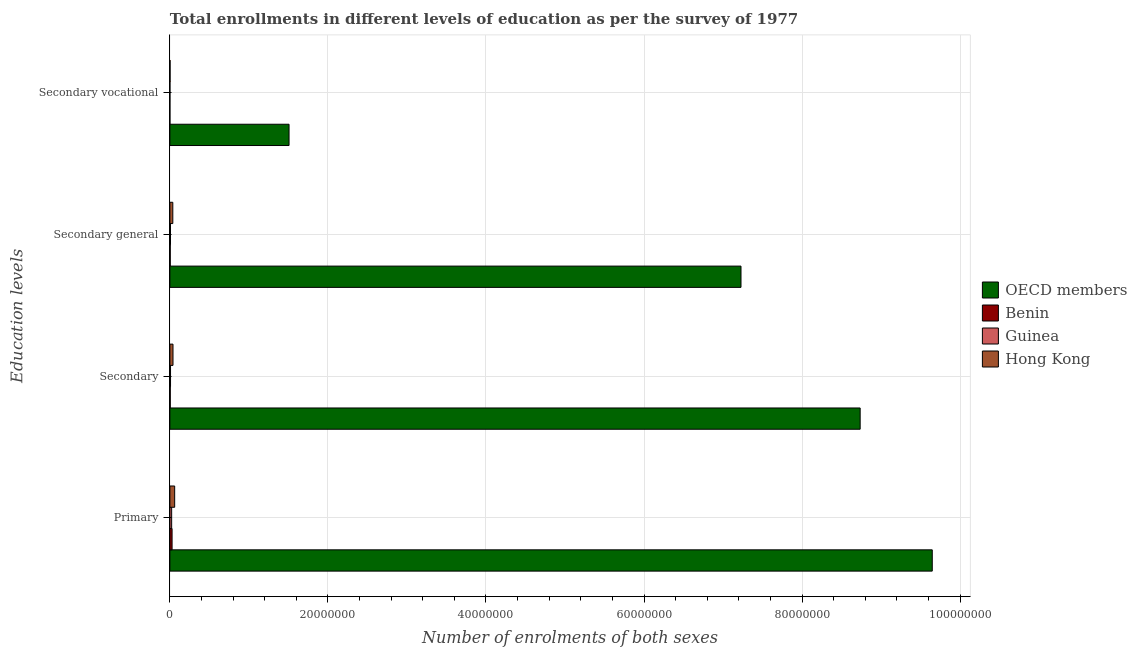How many different coloured bars are there?
Provide a short and direct response. 4. Are the number of bars per tick equal to the number of legend labels?
Your response must be concise. Yes. What is the label of the 4th group of bars from the top?
Ensure brevity in your answer.  Primary. What is the number of enrolments in secondary education in Benin?
Provide a succinct answer. 4.74e+04. Across all countries, what is the maximum number of enrolments in secondary general education?
Keep it short and to the point. 7.23e+07. Across all countries, what is the minimum number of enrolments in secondary education?
Provide a short and direct response. 4.74e+04. In which country was the number of enrolments in primary education minimum?
Provide a succinct answer. Guinea. What is the total number of enrolments in secondary education in the graph?
Offer a very short reply. 8.79e+07. What is the difference between the number of enrolments in primary education in OECD members and that in Benin?
Offer a terse response. 9.62e+07. What is the difference between the number of enrolments in secondary education in Benin and the number of enrolments in secondary general education in Guinea?
Provide a succinct answer. -3.11e+04. What is the average number of enrolments in secondary general education per country?
Keep it short and to the point. 1.82e+07. What is the difference between the number of enrolments in secondary general education and number of enrolments in secondary vocational education in Benin?
Your answer should be compact. 4.38e+04. In how many countries, is the number of enrolments in secondary vocational education greater than 32000000 ?
Make the answer very short. 0. What is the ratio of the number of enrolments in secondary education in Guinea to that in OECD members?
Offer a terse response. 0. Is the difference between the number of enrolments in secondary vocational education in OECD members and Benin greater than the difference between the number of enrolments in secondary education in OECD members and Benin?
Offer a very short reply. No. What is the difference between the highest and the second highest number of enrolments in secondary general education?
Keep it short and to the point. 7.19e+07. What is the difference between the highest and the lowest number of enrolments in secondary education?
Provide a succinct answer. 8.73e+07. What does the 3rd bar from the top in Primary represents?
Your answer should be very brief. Benin. Are all the bars in the graph horizontal?
Provide a short and direct response. Yes. Are the values on the major ticks of X-axis written in scientific E-notation?
Your answer should be very brief. No. How many legend labels are there?
Your response must be concise. 4. What is the title of the graph?
Ensure brevity in your answer.  Total enrollments in different levels of education as per the survey of 1977. Does "Ethiopia" appear as one of the legend labels in the graph?
Offer a very short reply. No. What is the label or title of the X-axis?
Offer a very short reply. Number of enrolments of both sexes. What is the label or title of the Y-axis?
Provide a succinct answer. Education levels. What is the Number of enrolments of both sexes in OECD members in Primary?
Ensure brevity in your answer.  9.65e+07. What is the Number of enrolments of both sexes in Benin in Primary?
Your answer should be very brief. 2.80e+05. What is the Number of enrolments of both sexes in Guinea in Primary?
Your response must be concise. 2.26e+05. What is the Number of enrolments of both sexes of Hong Kong in Primary?
Keep it short and to the point. 6.07e+05. What is the Number of enrolments of both sexes in OECD members in Secondary?
Keep it short and to the point. 8.73e+07. What is the Number of enrolments of both sexes in Benin in Secondary?
Provide a short and direct response. 4.74e+04. What is the Number of enrolments of both sexes in Guinea in Secondary?
Offer a terse response. 8.30e+04. What is the Number of enrolments of both sexes of Hong Kong in Secondary?
Your answer should be compact. 3.96e+05. What is the Number of enrolments of both sexes in OECD members in Secondary general?
Give a very brief answer. 7.23e+07. What is the Number of enrolments of both sexes of Benin in Secondary general?
Offer a very short reply. 4.56e+04. What is the Number of enrolments of both sexes in Guinea in Secondary general?
Ensure brevity in your answer.  7.85e+04. What is the Number of enrolments of both sexes in Hong Kong in Secondary general?
Make the answer very short. 3.72e+05. What is the Number of enrolments of both sexes of OECD members in Secondary vocational?
Give a very brief answer. 1.51e+07. What is the Number of enrolments of both sexes in Benin in Secondary vocational?
Offer a very short reply. 1798. What is the Number of enrolments of both sexes of Guinea in Secondary vocational?
Make the answer very short. 4560. What is the Number of enrolments of both sexes in Hong Kong in Secondary vocational?
Keep it short and to the point. 2.35e+04. Across all Education levels, what is the maximum Number of enrolments of both sexes of OECD members?
Ensure brevity in your answer.  9.65e+07. Across all Education levels, what is the maximum Number of enrolments of both sexes of Benin?
Your answer should be very brief. 2.80e+05. Across all Education levels, what is the maximum Number of enrolments of both sexes of Guinea?
Your response must be concise. 2.26e+05. Across all Education levels, what is the maximum Number of enrolments of both sexes of Hong Kong?
Keep it short and to the point. 6.07e+05. Across all Education levels, what is the minimum Number of enrolments of both sexes in OECD members?
Provide a succinct answer. 1.51e+07. Across all Education levels, what is the minimum Number of enrolments of both sexes in Benin?
Ensure brevity in your answer.  1798. Across all Education levels, what is the minimum Number of enrolments of both sexes in Guinea?
Make the answer very short. 4560. Across all Education levels, what is the minimum Number of enrolments of both sexes in Hong Kong?
Keep it short and to the point. 2.35e+04. What is the total Number of enrolments of both sexes of OECD members in the graph?
Make the answer very short. 2.71e+08. What is the total Number of enrolments of both sexes in Benin in the graph?
Provide a short and direct response. 3.74e+05. What is the total Number of enrolments of both sexes in Guinea in the graph?
Your answer should be very brief. 3.92e+05. What is the total Number of enrolments of both sexes in Hong Kong in the graph?
Provide a short and direct response. 1.40e+06. What is the difference between the Number of enrolments of both sexes of OECD members in Primary and that in Secondary?
Provide a succinct answer. 9.12e+06. What is the difference between the Number of enrolments of both sexes in Benin in Primary and that in Secondary?
Offer a terse response. 2.32e+05. What is the difference between the Number of enrolments of both sexes in Guinea in Primary and that in Secondary?
Offer a terse response. 1.43e+05. What is the difference between the Number of enrolments of both sexes of Hong Kong in Primary and that in Secondary?
Ensure brevity in your answer.  2.11e+05. What is the difference between the Number of enrolments of both sexes of OECD members in Primary and that in Secondary general?
Give a very brief answer. 2.42e+07. What is the difference between the Number of enrolments of both sexes of Benin in Primary and that in Secondary general?
Keep it short and to the point. 2.34e+05. What is the difference between the Number of enrolments of both sexes in Guinea in Primary and that in Secondary general?
Make the answer very short. 1.47e+05. What is the difference between the Number of enrolments of both sexes in Hong Kong in Primary and that in Secondary general?
Your answer should be compact. 2.35e+05. What is the difference between the Number of enrolments of both sexes in OECD members in Primary and that in Secondary vocational?
Keep it short and to the point. 8.14e+07. What is the difference between the Number of enrolments of both sexes in Benin in Primary and that in Secondary vocational?
Keep it short and to the point. 2.78e+05. What is the difference between the Number of enrolments of both sexes in Guinea in Primary and that in Secondary vocational?
Keep it short and to the point. 2.21e+05. What is the difference between the Number of enrolments of both sexes of Hong Kong in Primary and that in Secondary vocational?
Make the answer very short. 5.83e+05. What is the difference between the Number of enrolments of both sexes of OECD members in Secondary and that in Secondary general?
Keep it short and to the point. 1.51e+07. What is the difference between the Number of enrolments of both sexes of Benin in Secondary and that in Secondary general?
Make the answer very short. 1798. What is the difference between the Number of enrolments of both sexes of Guinea in Secondary and that in Secondary general?
Your answer should be compact. 4560. What is the difference between the Number of enrolments of both sexes in Hong Kong in Secondary and that in Secondary general?
Ensure brevity in your answer.  2.35e+04. What is the difference between the Number of enrolments of both sexes of OECD members in Secondary and that in Secondary vocational?
Make the answer very short. 7.23e+07. What is the difference between the Number of enrolments of both sexes of Benin in Secondary and that in Secondary vocational?
Keep it short and to the point. 4.56e+04. What is the difference between the Number of enrolments of both sexes in Guinea in Secondary and that in Secondary vocational?
Offer a very short reply. 7.85e+04. What is the difference between the Number of enrolments of both sexes in Hong Kong in Secondary and that in Secondary vocational?
Provide a succinct answer. 3.72e+05. What is the difference between the Number of enrolments of both sexes of OECD members in Secondary general and that in Secondary vocational?
Your answer should be very brief. 5.72e+07. What is the difference between the Number of enrolments of both sexes of Benin in Secondary general and that in Secondary vocational?
Your answer should be compact. 4.38e+04. What is the difference between the Number of enrolments of both sexes of Guinea in Secondary general and that in Secondary vocational?
Your answer should be very brief. 7.39e+04. What is the difference between the Number of enrolments of both sexes of Hong Kong in Secondary general and that in Secondary vocational?
Offer a terse response. 3.49e+05. What is the difference between the Number of enrolments of both sexes in OECD members in Primary and the Number of enrolments of both sexes in Benin in Secondary?
Your response must be concise. 9.64e+07. What is the difference between the Number of enrolments of both sexes of OECD members in Primary and the Number of enrolments of both sexes of Guinea in Secondary?
Provide a short and direct response. 9.64e+07. What is the difference between the Number of enrolments of both sexes of OECD members in Primary and the Number of enrolments of both sexes of Hong Kong in Secondary?
Your answer should be compact. 9.61e+07. What is the difference between the Number of enrolments of both sexes in Benin in Primary and the Number of enrolments of both sexes in Guinea in Secondary?
Your answer should be compact. 1.97e+05. What is the difference between the Number of enrolments of both sexes in Benin in Primary and the Number of enrolments of both sexes in Hong Kong in Secondary?
Your answer should be very brief. -1.16e+05. What is the difference between the Number of enrolments of both sexes of Guinea in Primary and the Number of enrolments of both sexes of Hong Kong in Secondary?
Offer a very short reply. -1.70e+05. What is the difference between the Number of enrolments of both sexes in OECD members in Primary and the Number of enrolments of both sexes in Benin in Secondary general?
Provide a short and direct response. 9.64e+07. What is the difference between the Number of enrolments of both sexes in OECD members in Primary and the Number of enrolments of both sexes in Guinea in Secondary general?
Offer a very short reply. 9.64e+07. What is the difference between the Number of enrolments of both sexes in OECD members in Primary and the Number of enrolments of both sexes in Hong Kong in Secondary general?
Keep it short and to the point. 9.61e+07. What is the difference between the Number of enrolments of both sexes of Benin in Primary and the Number of enrolments of both sexes of Guinea in Secondary general?
Provide a short and direct response. 2.01e+05. What is the difference between the Number of enrolments of both sexes of Benin in Primary and the Number of enrolments of both sexes of Hong Kong in Secondary general?
Offer a very short reply. -9.24e+04. What is the difference between the Number of enrolments of both sexes of Guinea in Primary and the Number of enrolments of both sexes of Hong Kong in Secondary general?
Offer a very short reply. -1.46e+05. What is the difference between the Number of enrolments of both sexes of OECD members in Primary and the Number of enrolments of both sexes of Benin in Secondary vocational?
Offer a terse response. 9.65e+07. What is the difference between the Number of enrolments of both sexes in OECD members in Primary and the Number of enrolments of both sexes in Guinea in Secondary vocational?
Provide a succinct answer. 9.65e+07. What is the difference between the Number of enrolments of both sexes in OECD members in Primary and the Number of enrolments of both sexes in Hong Kong in Secondary vocational?
Provide a short and direct response. 9.64e+07. What is the difference between the Number of enrolments of both sexes in Benin in Primary and the Number of enrolments of both sexes in Guinea in Secondary vocational?
Offer a terse response. 2.75e+05. What is the difference between the Number of enrolments of both sexes in Benin in Primary and the Number of enrolments of both sexes in Hong Kong in Secondary vocational?
Make the answer very short. 2.56e+05. What is the difference between the Number of enrolments of both sexes of Guinea in Primary and the Number of enrolments of both sexes of Hong Kong in Secondary vocational?
Offer a very short reply. 2.02e+05. What is the difference between the Number of enrolments of both sexes of OECD members in Secondary and the Number of enrolments of both sexes of Benin in Secondary general?
Your response must be concise. 8.73e+07. What is the difference between the Number of enrolments of both sexes in OECD members in Secondary and the Number of enrolments of both sexes in Guinea in Secondary general?
Offer a terse response. 8.73e+07. What is the difference between the Number of enrolments of both sexes of OECD members in Secondary and the Number of enrolments of both sexes of Hong Kong in Secondary general?
Offer a very short reply. 8.70e+07. What is the difference between the Number of enrolments of both sexes of Benin in Secondary and the Number of enrolments of both sexes of Guinea in Secondary general?
Keep it short and to the point. -3.11e+04. What is the difference between the Number of enrolments of both sexes in Benin in Secondary and the Number of enrolments of both sexes in Hong Kong in Secondary general?
Keep it short and to the point. -3.25e+05. What is the difference between the Number of enrolments of both sexes of Guinea in Secondary and the Number of enrolments of both sexes of Hong Kong in Secondary general?
Provide a short and direct response. -2.89e+05. What is the difference between the Number of enrolments of both sexes in OECD members in Secondary and the Number of enrolments of both sexes in Benin in Secondary vocational?
Provide a succinct answer. 8.73e+07. What is the difference between the Number of enrolments of both sexes of OECD members in Secondary and the Number of enrolments of both sexes of Guinea in Secondary vocational?
Provide a succinct answer. 8.73e+07. What is the difference between the Number of enrolments of both sexes of OECD members in Secondary and the Number of enrolments of both sexes of Hong Kong in Secondary vocational?
Provide a succinct answer. 8.73e+07. What is the difference between the Number of enrolments of both sexes of Benin in Secondary and the Number of enrolments of both sexes of Guinea in Secondary vocational?
Your response must be concise. 4.28e+04. What is the difference between the Number of enrolments of both sexes of Benin in Secondary and the Number of enrolments of both sexes of Hong Kong in Secondary vocational?
Keep it short and to the point. 2.38e+04. What is the difference between the Number of enrolments of both sexes of Guinea in Secondary and the Number of enrolments of both sexes of Hong Kong in Secondary vocational?
Your response must be concise. 5.95e+04. What is the difference between the Number of enrolments of both sexes in OECD members in Secondary general and the Number of enrolments of both sexes in Benin in Secondary vocational?
Provide a succinct answer. 7.23e+07. What is the difference between the Number of enrolments of both sexes of OECD members in Secondary general and the Number of enrolments of both sexes of Guinea in Secondary vocational?
Offer a terse response. 7.23e+07. What is the difference between the Number of enrolments of both sexes in OECD members in Secondary general and the Number of enrolments of both sexes in Hong Kong in Secondary vocational?
Your answer should be compact. 7.22e+07. What is the difference between the Number of enrolments of both sexes of Benin in Secondary general and the Number of enrolments of both sexes of Guinea in Secondary vocational?
Offer a very short reply. 4.10e+04. What is the difference between the Number of enrolments of both sexes in Benin in Secondary general and the Number of enrolments of both sexes in Hong Kong in Secondary vocational?
Offer a very short reply. 2.21e+04. What is the difference between the Number of enrolments of both sexes of Guinea in Secondary general and the Number of enrolments of both sexes of Hong Kong in Secondary vocational?
Keep it short and to the point. 5.49e+04. What is the average Number of enrolments of both sexes in OECD members per Education levels?
Ensure brevity in your answer.  6.78e+07. What is the average Number of enrolments of both sexes of Benin per Education levels?
Give a very brief answer. 9.36e+04. What is the average Number of enrolments of both sexes of Guinea per Education levels?
Keep it short and to the point. 9.79e+04. What is the average Number of enrolments of both sexes of Hong Kong per Education levels?
Provide a short and direct response. 3.50e+05. What is the difference between the Number of enrolments of both sexes in OECD members and Number of enrolments of both sexes in Benin in Primary?
Keep it short and to the point. 9.62e+07. What is the difference between the Number of enrolments of both sexes of OECD members and Number of enrolments of both sexes of Guinea in Primary?
Keep it short and to the point. 9.62e+07. What is the difference between the Number of enrolments of both sexes of OECD members and Number of enrolments of both sexes of Hong Kong in Primary?
Keep it short and to the point. 9.59e+07. What is the difference between the Number of enrolments of both sexes of Benin and Number of enrolments of both sexes of Guinea in Primary?
Offer a very short reply. 5.39e+04. What is the difference between the Number of enrolments of both sexes of Benin and Number of enrolments of both sexes of Hong Kong in Primary?
Ensure brevity in your answer.  -3.27e+05. What is the difference between the Number of enrolments of both sexes in Guinea and Number of enrolments of both sexes in Hong Kong in Primary?
Offer a very short reply. -3.81e+05. What is the difference between the Number of enrolments of both sexes of OECD members and Number of enrolments of both sexes of Benin in Secondary?
Offer a very short reply. 8.73e+07. What is the difference between the Number of enrolments of both sexes in OECD members and Number of enrolments of both sexes in Guinea in Secondary?
Provide a succinct answer. 8.73e+07. What is the difference between the Number of enrolments of both sexes of OECD members and Number of enrolments of both sexes of Hong Kong in Secondary?
Give a very brief answer. 8.70e+07. What is the difference between the Number of enrolments of both sexes in Benin and Number of enrolments of both sexes in Guinea in Secondary?
Your response must be concise. -3.56e+04. What is the difference between the Number of enrolments of both sexes of Benin and Number of enrolments of both sexes of Hong Kong in Secondary?
Provide a short and direct response. -3.48e+05. What is the difference between the Number of enrolments of both sexes in Guinea and Number of enrolments of both sexes in Hong Kong in Secondary?
Provide a short and direct response. -3.13e+05. What is the difference between the Number of enrolments of both sexes of OECD members and Number of enrolments of both sexes of Benin in Secondary general?
Provide a short and direct response. 7.22e+07. What is the difference between the Number of enrolments of both sexes in OECD members and Number of enrolments of both sexes in Guinea in Secondary general?
Your response must be concise. 7.22e+07. What is the difference between the Number of enrolments of both sexes of OECD members and Number of enrolments of both sexes of Hong Kong in Secondary general?
Make the answer very short. 7.19e+07. What is the difference between the Number of enrolments of both sexes of Benin and Number of enrolments of both sexes of Guinea in Secondary general?
Your answer should be compact. -3.29e+04. What is the difference between the Number of enrolments of both sexes of Benin and Number of enrolments of both sexes of Hong Kong in Secondary general?
Keep it short and to the point. -3.27e+05. What is the difference between the Number of enrolments of both sexes of Guinea and Number of enrolments of both sexes of Hong Kong in Secondary general?
Your answer should be compact. -2.94e+05. What is the difference between the Number of enrolments of both sexes in OECD members and Number of enrolments of both sexes in Benin in Secondary vocational?
Make the answer very short. 1.51e+07. What is the difference between the Number of enrolments of both sexes in OECD members and Number of enrolments of both sexes in Guinea in Secondary vocational?
Your answer should be compact. 1.51e+07. What is the difference between the Number of enrolments of both sexes in OECD members and Number of enrolments of both sexes in Hong Kong in Secondary vocational?
Provide a succinct answer. 1.51e+07. What is the difference between the Number of enrolments of both sexes in Benin and Number of enrolments of both sexes in Guinea in Secondary vocational?
Your response must be concise. -2762. What is the difference between the Number of enrolments of both sexes in Benin and Number of enrolments of both sexes in Hong Kong in Secondary vocational?
Provide a short and direct response. -2.17e+04. What is the difference between the Number of enrolments of both sexes in Guinea and Number of enrolments of both sexes in Hong Kong in Secondary vocational?
Provide a short and direct response. -1.90e+04. What is the ratio of the Number of enrolments of both sexes of OECD members in Primary to that in Secondary?
Your answer should be compact. 1.1. What is the ratio of the Number of enrolments of both sexes of Benin in Primary to that in Secondary?
Your answer should be compact. 5.9. What is the ratio of the Number of enrolments of both sexes of Guinea in Primary to that in Secondary?
Give a very brief answer. 2.72. What is the ratio of the Number of enrolments of both sexes of Hong Kong in Primary to that in Secondary?
Provide a succinct answer. 1.53. What is the ratio of the Number of enrolments of both sexes in OECD members in Primary to that in Secondary general?
Your answer should be compact. 1.33. What is the ratio of the Number of enrolments of both sexes in Benin in Primary to that in Secondary general?
Your answer should be compact. 6.14. What is the ratio of the Number of enrolments of both sexes of Guinea in Primary to that in Secondary general?
Offer a very short reply. 2.88. What is the ratio of the Number of enrolments of both sexes of Hong Kong in Primary to that in Secondary general?
Make the answer very short. 1.63. What is the ratio of the Number of enrolments of both sexes of OECD members in Primary to that in Secondary vocational?
Offer a terse response. 6.4. What is the ratio of the Number of enrolments of both sexes in Benin in Primary to that in Secondary vocational?
Your response must be concise. 155.55. What is the ratio of the Number of enrolments of both sexes in Guinea in Primary to that in Secondary vocational?
Your response must be concise. 49.5. What is the ratio of the Number of enrolments of both sexes in Hong Kong in Primary to that in Secondary vocational?
Your answer should be very brief. 25.8. What is the ratio of the Number of enrolments of both sexes of OECD members in Secondary to that in Secondary general?
Provide a short and direct response. 1.21. What is the ratio of the Number of enrolments of both sexes of Benin in Secondary to that in Secondary general?
Your response must be concise. 1.04. What is the ratio of the Number of enrolments of both sexes in Guinea in Secondary to that in Secondary general?
Offer a very short reply. 1.06. What is the ratio of the Number of enrolments of both sexes of Hong Kong in Secondary to that in Secondary general?
Keep it short and to the point. 1.06. What is the ratio of the Number of enrolments of both sexes in OECD members in Secondary to that in Secondary vocational?
Offer a very short reply. 5.79. What is the ratio of the Number of enrolments of both sexes of Benin in Secondary to that in Secondary vocational?
Keep it short and to the point. 26.35. What is the ratio of the Number of enrolments of both sexes in Guinea in Secondary to that in Secondary vocational?
Your response must be concise. 18.21. What is the ratio of the Number of enrolments of both sexes in Hong Kong in Secondary to that in Secondary vocational?
Ensure brevity in your answer.  16.82. What is the ratio of the Number of enrolments of both sexes in OECD members in Secondary general to that in Secondary vocational?
Your response must be concise. 4.79. What is the ratio of the Number of enrolments of both sexes of Benin in Secondary general to that in Secondary vocational?
Your response must be concise. 25.35. What is the ratio of the Number of enrolments of both sexes in Guinea in Secondary general to that in Secondary vocational?
Provide a succinct answer. 17.21. What is the ratio of the Number of enrolments of both sexes of Hong Kong in Secondary general to that in Secondary vocational?
Your response must be concise. 15.82. What is the difference between the highest and the second highest Number of enrolments of both sexes in OECD members?
Offer a very short reply. 9.12e+06. What is the difference between the highest and the second highest Number of enrolments of both sexes in Benin?
Offer a terse response. 2.32e+05. What is the difference between the highest and the second highest Number of enrolments of both sexes of Guinea?
Make the answer very short. 1.43e+05. What is the difference between the highest and the second highest Number of enrolments of both sexes in Hong Kong?
Make the answer very short. 2.11e+05. What is the difference between the highest and the lowest Number of enrolments of both sexes of OECD members?
Your answer should be very brief. 8.14e+07. What is the difference between the highest and the lowest Number of enrolments of both sexes of Benin?
Your answer should be very brief. 2.78e+05. What is the difference between the highest and the lowest Number of enrolments of both sexes in Guinea?
Give a very brief answer. 2.21e+05. What is the difference between the highest and the lowest Number of enrolments of both sexes of Hong Kong?
Keep it short and to the point. 5.83e+05. 